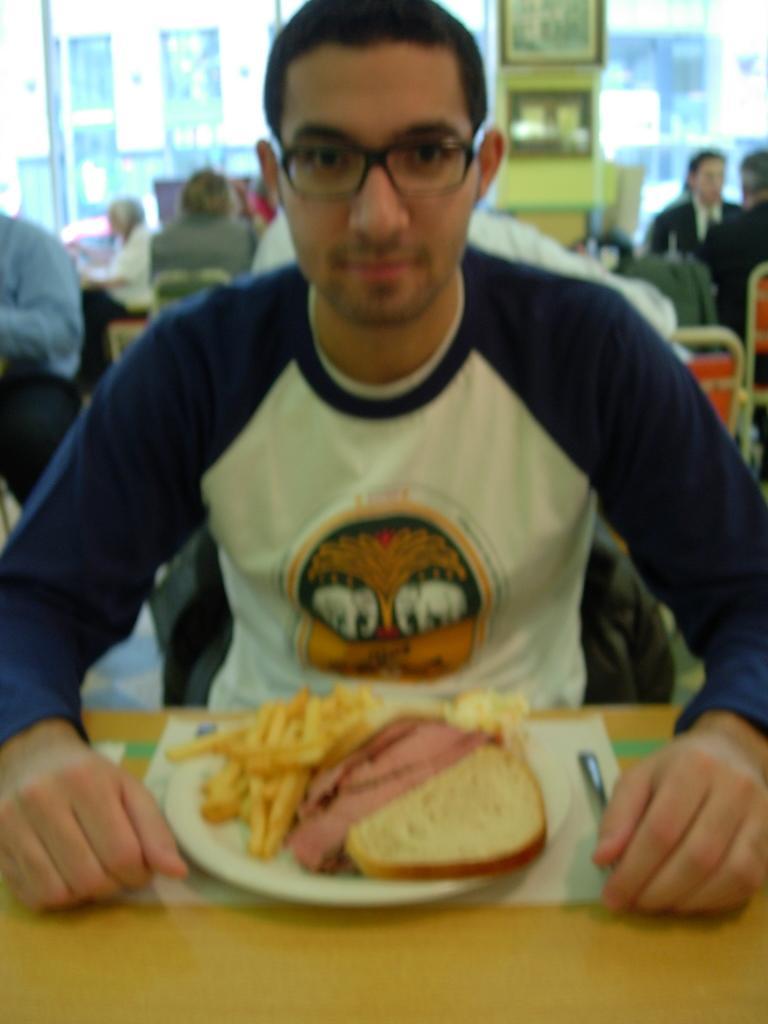Please provide a concise description of this image. In this image there are people sitting. At the bottom there is a table and we can see a plate containing food, spoon and a napkin placed on the table. In the background there is a wall and we can see an object. 